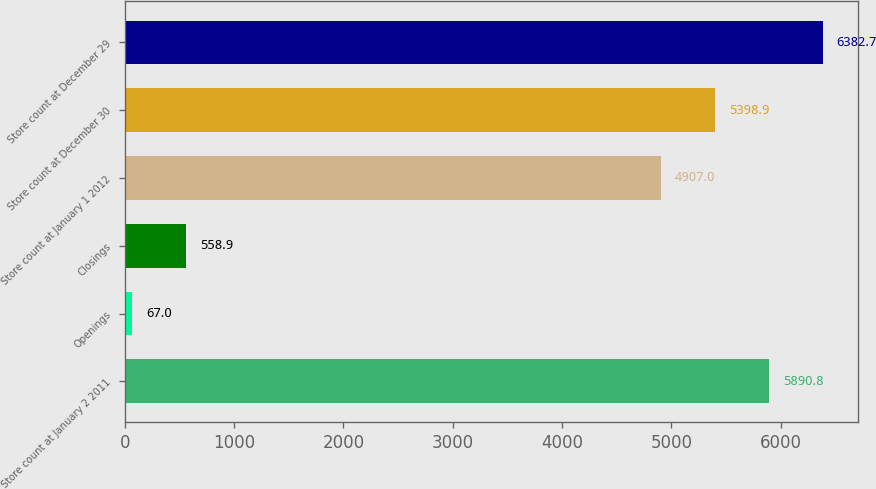Convert chart. <chart><loc_0><loc_0><loc_500><loc_500><bar_chart><fcel>Store count at January 2 2011<fcel>Openings<fcel>Closings<fcel>Store count at January 1 2012<fcel>Store count at December 30<fcel>Store count at December 29<nl><fcel>5890.8<fcel>67<fcel>558.9<fcel>4907<fcel>5398.9<fcel>6382.7<nl></chart> 